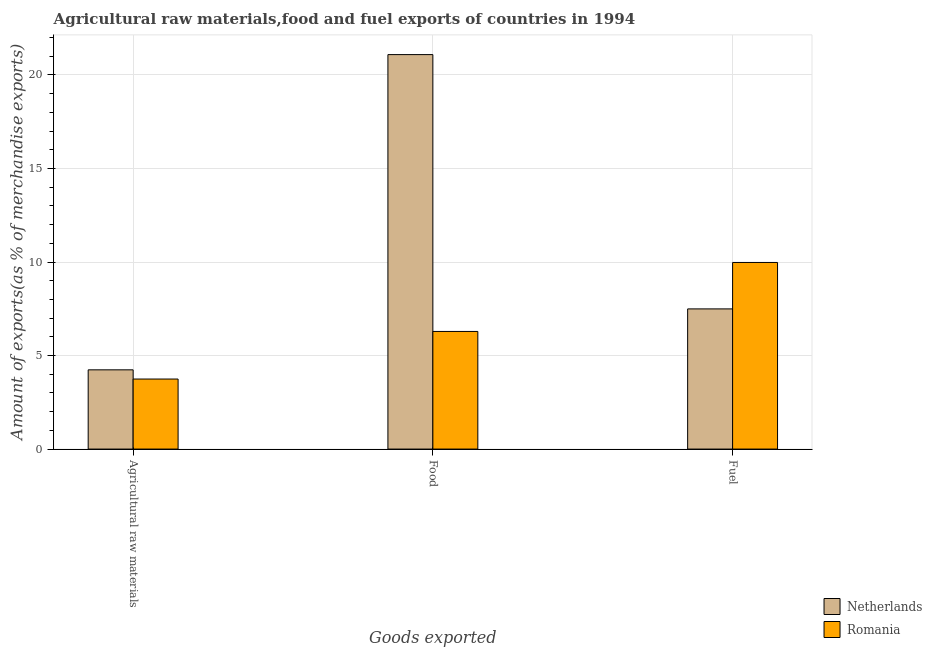How many groups of bars are there?
Your answer should be very brief. 3. Are the number of bars per tick equal to the number of legend labels?
Ensure brevity in your answer.  Yes. How many bars are there on the 3rd tick from the right?
Keep it short and to the point. 2. What is the label of the 1st group of bars from the left?
Offer a terse response. Agricultural raw materials. What is the percentage of fuel exports in Netherlands?
Ensure brevity in your answer.  7.49. Across all countries, what is the maximum percentage of food exports?
Offer a terse response. 21.09. Across all countries, what is the minimum percentage of food exports?
Provide a succinct answer. 6.29. In which country was the percentage of fuel exports maximum?
Give a very brief answer. Romania. In which country was the percentage of food exports minimum?
Keep it short and to the point. Romania. What is the total percentage of food exports in the graph?
Offer a terse response. 27.38. What is the difference between the percentage of food exports in Romania and that in Netherlands?
Your answer should be very brief. -14.8. What is the difference between the percentage of food exports in Romania and the percentage of raw materials exports in Netherlands?
Provide a succinct answer. 2.05. What is the average percentage of fuel exports per country?
Offer a very short reply. 8.74. What is the difference between the percentage of food exports and percentage of raw materials exports in Netherlands?
Offer a terse response. 16.85. What is the ratio of the percentage of fuel exports in Romania to that in Netherlands?
Offer a terse response. 1.33. What is the difference between the highest and the second highest percentage of raw materials exports?
Offer a very short reply. 0.49. What is the difference between the highest and the lowest percentage of fuel exports?
Make the answer very short. 2.48. Is the sum of the percentage of raw materials exports in Romania and Netherlands greater than the maximum percentage of fuel exports across all countries?
Provide a succinct answer. No. What does the 2nd bar from the left in Agricultural raw materials represents?
Your response must be concise. Romania. What does the 2nd bar from the right in Food represents?
Your answer should be very brief. Netherlands. Is it the case that in every country, the sum of the percentage of raw materials exports and percentage of food exports is greater than the percentage of fuel exports?
Ensure brevity in your answer.  Yes. Are all the bars in the graph horizontal?
Keep it short and to the point. No. How many countries are there in the graph?
Keep it short and to the point. 2. What is the difference between two consecutive major ticks on the Y-axis?
Your answer should be very brief. 5. Does the graph contain grids?
Your answer should be compact. Yes. How are the legend labels stacked?
Ensure brevity in your answer.  Vertical. What is the title of the graph?
Provide a succinct answer. Agricultural raw materials,food and fuel exports of countries in 1994. What is the label or title of the X-axis?
Your answer should be very brief. Goods exported. What is the label or title of the Y-axis?
Make the answer very short. Amount of exports(as % of merchandise exports). What is the Amount of exports(as % of merchandise exports) of Netherlands in Agricultural raw materials?
Keep it short and to the point. 4.24. What is the Amount of exports(as % of merchandise exports) of Romania in Agricultural raw materials?
Your response must be concise. 3.74. What is the Amount of exports(as % of merchandise exports) of Netherlands in Food?
Provide a succinct answer. 21.09. What is the Amount of exports(as % of merchandise exports) of Romania in Food?
Keep it short and to the point. 6.29. What is the Amount of exports(as % of merchandise exports) in Netherlands in Fuel?
Offer a terse response. 7.49. What is the Amount of exports(as % of merchandise exports) in Romania in Fuel?
Provide a short and direct response. 9.98. Across all Goods exported, what is the maximum Amount of exports(as % of merchandise exports) of Netherlands?
Provide a short and direct response. 21.09. Across all Goods exported, what is the maximum Amount of exports(as % of merchandise exports) in Romania?
Make the answer very short. 9.98. Across all Goods exported, what is the minimum Amount of exports(as % of merchandise exports) of Netherlands?
Make the answer very short. 4.24. Across all Goods exported, what is the minimum Amount of exports(as % of merchandise exports) of Romania?
Provide a short and direct response. 3.74. What is the total Amount of exports(as % of merchandise exports) in Netherlands in the graph?
Your response must be concise. 32.82. What is the total Amount of exports(as % of merchandise exports) in Romania in the graph?
Ensure brevity in your answer.  20.01. What is the difference between the Amount of exports(as % of merchandise exports) in Netherlands in Agricultural raw materials and that in Food?
Offer a very short reply. -16.85. What is the difference between the Amount of exports(as % of merchandise exports) of Romania in Agricultural raw materials and that in Food?
Ensure brevity in your answer.  -2.54. What is the difference between the Amount of exports(as % of merchandise exports) in Netherlands in Agricultural raw materials and that in Fuel?
Your answer should be compact. -3.26. What is the difference between the Amount of exports(as % of merchandise exports) in Romania in Agricultural raw materials and that in Fuel?
Your answer should be compact. -6.23. What is the difference between the Amount of exports(as % of merchandise exports) in Netherlands in Food and that in Fuel?
Offer a terse response. 13.6. What is the difference between the Amount of exports(as % of merchandise exports) of Romania in Food and that in Fuel?
Offer a terse response. -3.69. What is the difference between the Amount of exports(as % of merchandise exports) in Netherlands in Agricultural raw materials and the Amount of exports(as % of merchandise exports) in Romania in Food?
Your response must be concise. -2.05. What is the difference between the Amount of exports(as % of merchandise exports) in Netherlands in Agricultural raw materials and the Amount of exports(as % of merchandise exports) in Romania in Fuel?
Your response must be concise. -5.74. What is the difference between the Amount of exports(as % of merchandise exports) in Netherlands in Food and the Amount of exports(as % of merchandise exports) in Romania in Fuel?
Keep it short and to the point. 11.11. What is the average Amount of exports(as % of merchandise exports) of Netherlands per Goods exported?
Ensure brevity in your answer.  10.94. What is the average Amount of exports(as % of merchandise exports) in Romania per Goods exported?
Your answer should be compact. 6.67. What is the difference between the Amount of exports(as % of merchandise exports) of Netherlands and Amount of exports(as % of merchandise exports) of Romania in Agricultural raw materials?
Provide a short and direct response. 0.49. What is the difference between the Amount of exports(as % of merchandise exports) in Netherlands and Amount of exports(as % of merchandise exports) in Romania in Food?
Keep it short and to the point. 14.8. What is the difference between the Amount of exports(as % of merchandise exports) in Netherlands and Amount of exports(as % of merchandise exports) in Romania in Fuel?
Offer a very short reply. -2.48. What is the ratio of the Amount of exports(as % of merchandise exports) in Netherlands in Agricultural raw materials to that in Food?
Your answer should be very brief. 0.2. What is the ratio of the Amount of exports(as % of merchandise exports) of Romania in Agricultural raw materials to that in Food?
Provide a succinct answer. 0.6. What is the ratio of the Amount of exports(as % of merchandise exports) of Netherlands in Agricultural raw materials to that in Fuel?
Make the answer very short. 0.57. What is the ratio of the Amount of exports(as % of merchandise exports) of Romania in Agricultural raw materials to that in Fuel?
Ensure brevity in your answer.  0.38. What is the ratio of the Amount of exports(as % of merchandise exports) in Netherlands in Food to that in Fuel?
Offer a very short reply. 2.81. What is the ratio of the Amount of exports(as % of merchandise exports) of Romania in Food to that in Fuel?
Make the answer very short. 0.63. What is the difference between the highest and the second highest Amount of exports(as % of merchandise exports) of Netherlands?
Ensure brevity in your answer.  13.6. What is the difference between the highest and the second highest Amount of exports(as % of merchandise exports) in Romania?
Your answer should be very brief. 3.69. What is the difference between the highest and the lowest Amount of exports(as % of merchandise exports) in Netherlands?
Your answer should be very brief. 16.85. What is the difference between the highest and the lowest Amount of exports(as % of merchandise exports) in Romania?
Keep it short and to the point. 6.23. 